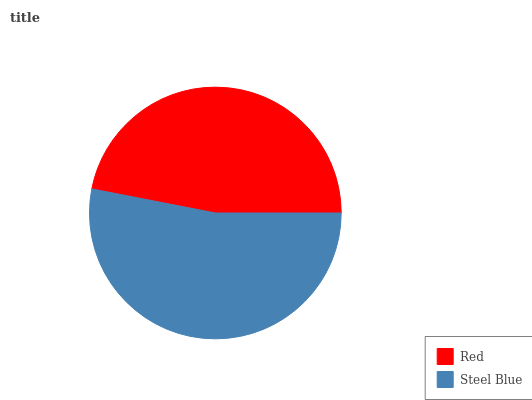Is Red the minimum?
Answer yes or no. Yes. Is Steel Blue the maximum?
Answer yes or no. Yes. Is Steel Blue the minimum?
Answer yes or no. No. Is Steel Blue greater than Red?
Answer yes or no. Yes. Is Red less than Steel Blue?
Answer yes or no. Yes. Is Red greater than Steel Blue?
Answer yes or no. No. Is Steel Blue less than Red?
Answer yes or no. No. Is Steel Blue the high median?
Answer yes or no. Yes. Is Red the low median?
Answer yes or no. Yes. Is Red the high median?
Answer yes or no. No. Is Steel Blue the low median?
Answer yes or no. No. 